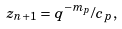<formula> <loc_0><loc_0><loc_500><loc_500>z _ { n + 1 } = q ^ { - m _ { p } } / c _ { p } ,</formula> 